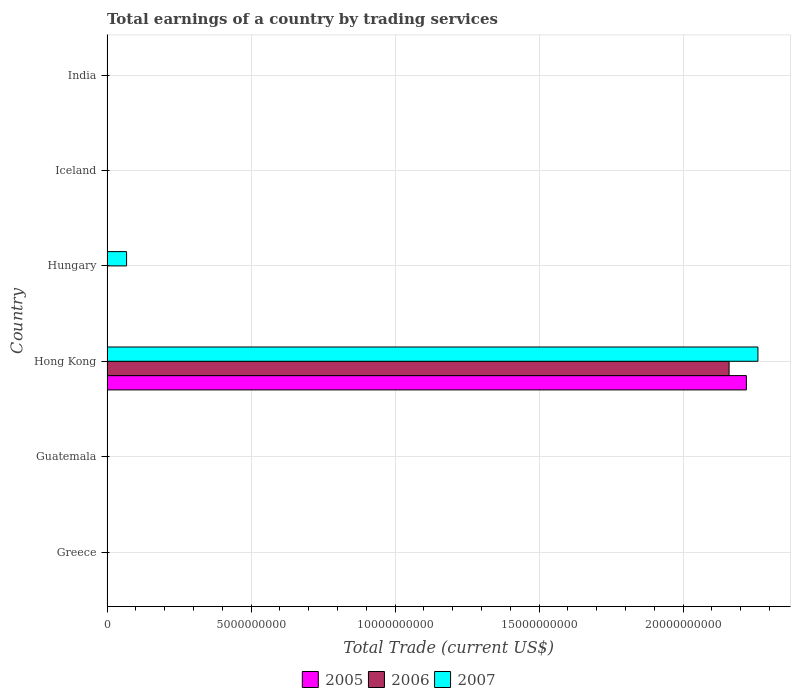Are the number of bars on each tick of the Y-axis equal?
Your answer should be compact. No. What is the label of the 2nd group of bars from the top?
Keep it short and to the point. Iceland. What is the total earnings in 2005 in India?
Provide a short and direct response. 0. Across all countries, what is the maximum total earnings in 2007?
Your answer should be compact. 2.26e+1. In which country was the total earnings in 2007 maximum?
Offer a very short reply. Hong Kong. What is the total total earnings in 2006 in the graph?
Keep it short and to the point. 2.16e+1. What is the difference between the total earnings in 2007 in Hong Kong and that in Hungary?
Your answer should be compact. 2.19e+1. What is the average total earnings in 2006 per country?
Offer a very short reply. 3.60e+09. What is the difference between the total earnings in 2007 and total earnings in 2006 in Hong Kong?
Make the answer very short. 1.00e+09. What is the difference between the highest and the lowest total earnings in 2005?
Offer a terse response. 2.22e+1. Is it the case that in every country, the sum of the total earnings in 2005 and total earnings in 2006 is greater than the total earnings in 2007?
Provide a short and direct response. No. How many bars are there?
Your answer should be compact. 4. Does the graph contain any zero values?
Offer a terse response. Yes. Does the graph contain grids?
Keep it short and to the point. Yes. How are the legend labels stacked?
Make the answer very short. Horizontal. What is the title of the graph?
Your answer should be compact. Total earnings of a country by trading services. What is the label or title of the X-axis?
Ensure brevity in your answer.  Total Trade (current US$). What is the Total Trade (current US$) of 2005 in Greece?
Offer a terse response. 0. What is the Total Trade (current US$) in 2006 in Greece?
Provide a succinct answer. 0. What is the Total Trade (current US$) of 2007 in Greece?
Give a very brief answer. 0. What is the Total Trade (current US$) in 2005 in Hong Kong?
Give a very brief answer. 2.22e+1. What is the Total Trade (current US$) of 2006 in Hong Kong?
Your answer should be very brief. 2.16e+1. What is the Total Trade (current US$) of 2007 in Hong Kong?
Provide a succinct answer. 2.26e+1. What is the Total Trade (current US$) of 2007 in Hungary?
Provide a short and direct response. 6.80e+08. What is the Total Trade (current US$) of 2005 in Iceland?
Ensure brevity in your answer.  0. What is the Total Trade (current US$) of 2006 in Iceland?
Offer a very short reply. 0. What is the Total Trade (current US$) of 2005 in India?
Your answer should be compact. 0. What is the Total Trade (current US$) of 2007 in India?
Offer a terse response. 0. Across all countries, what is the maximum Total Trade (current US$) of 2005?
Offer a terse response. 2.22e+1. Across all countries, what is the maximum Total Trade (current US$) of 2006?
Ensure brevity in your answer.  2.16e+1. Across all countries, what is the maximum Total Trade (current US$) of 2007?
Offer a very short reply. 2.26e+1. Across all countries, what is the minimum Total Trade (current US$) of 2005?
Offer a very short reply. 0. Across all countries, what is the minimum Total Trade (current US$) in 2007?
Give a very brief answer. 0. What is the total Total Trade (current US$) of 2005 in the graph?
Provide a succinct answer. 2.22e+1. What is the total Total Trade (current US$) of 2006 in the graph?
Offer a terse response. 2.16e+1. What is the total Total Trade (current US$) in 2007 in the graph?
Ensure brevity in your answer.  2.33e+1. What is the difference between the Total Trade (current US$) of 2007 in Hong Kong and that in Hungary?
Provide a succinct answer. 2.19e+1. What is the difference between the Total Trade (current US$) of 2005 in Hong Kong and the Total Trade (current US$) of 2007 in Hungary?
Ensure brevity in your answer.  2.15e+1. What is the difference between the Total Trade (current US$) of 2006 in Hong Kong and the Total Trade (current US$) of 2007 in Hungary?
Make the answer very short. 2.09e+1. What is the average Total Trade (current US$) of 2005 per country?
Offer a terse response. 3.70e+09. What is the average Total Trade (current US$) of 2006 per country?
Give a very brief answer. 3.60e+09. What is the average Total Trade (current US$) of 2007 per country?
Your answer should be compact. 3.88e+09. What is the difference between the Total Trade (current US$) of 2005 and Total Trade (current US$) of 2006 in Hong Kong?
Keep it short and to the point. 6.01e+08. What is the difference between the Total Trade (current US$) of 2005 and Total Trade (current US$) of 2007 in Hong Kong?
Your response must be concise. -4.01e+08. What is the difference between the Total Trade (current US$) in 2006 and Total Trade (current US$) in 2007 in Hong Kong?
Give a very brief answer. -1.00e+09. What is the ratio of the Total Trade (current US$) in 2007 in Hong Kong to that in Hungary?
Offer a terse response. 33.25. What is the difference between the highest and the lowest Total Trade (current US$) in 2005?
Keep it short and to the point. 2.22e+1. What is the difference between the highest and the lowest Total Trade (current US$) in 2006?
Offer a terse response. 2.16e+1. What is the difference between the highest and the lowest Total Trade (current US$) in 2007?
Make the answer very short. 2.26e+1. 